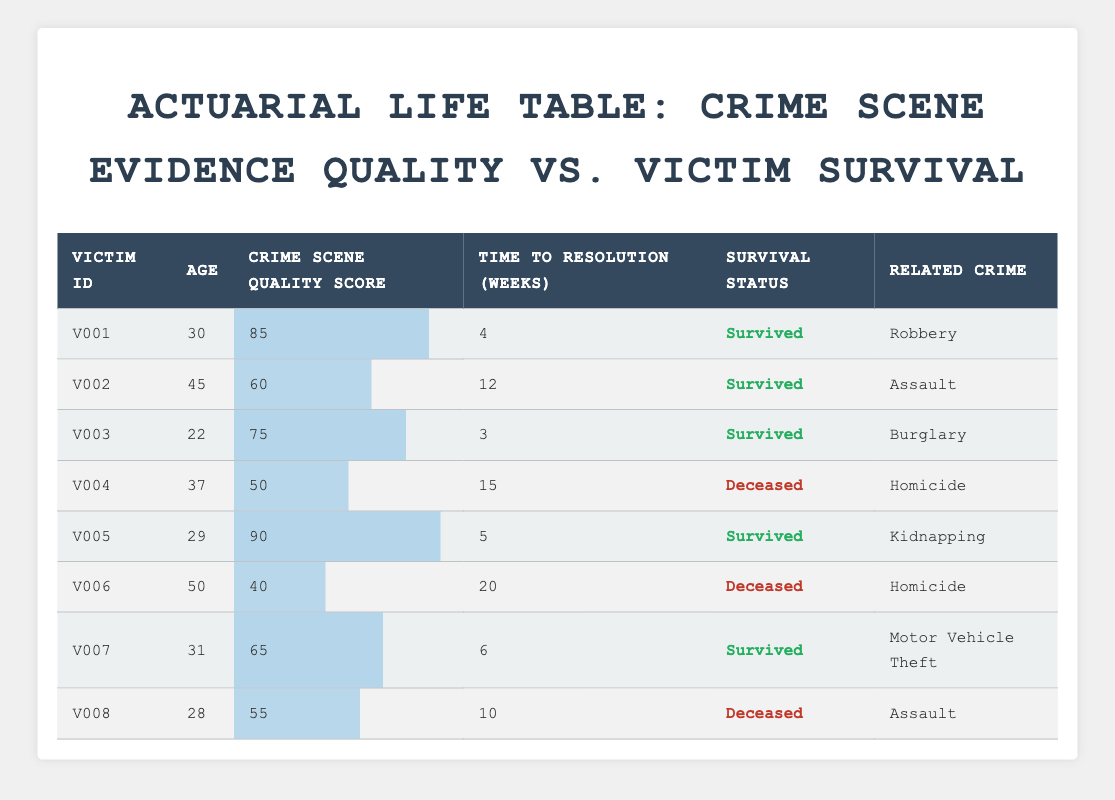What is the age of the youngest victim? By examining the age column, the youngest victim is identified as V003, who is 22 years old.
Answer: 22 How many victims survived their incidents? Counting the rows where the survival status is "Survived", we find that there are 5 victims (V001, V002, V003, V005, V007).
Answer: 5 What is the average crime scene quality score of deceased victims? The deceased victims are V004, V006, and V008 with scores of 50, 40, and 55 respectively. To find the average, sum these scores (50 + 40 + 55 = 145) and divide by the count (3). The average is 145 / 3 = 48.33.
Answer: 48.33 Which victim had the longest time to resolution, and how many weeks was it? Reviewing the time to resolution column, we see that the longest time is 20 weeks for victim V006.
Answer: V006, 20 weeks Is there any victim aged over 40 who survived? Looking through the age and survival status columns, we find that V002 (age 45) survived, so the answer is Yes.
Answer: Yes What is the total time to resolution for all victims who survived? Summing the time to resolution for survived victims (4 + 12 + 3 + 5 + 6 = 30) gives a total of 30 weeks.
Answer: 30 weeks How many victims related to homicide are in the data, and what were their survival statuses? Examining the related crime column, we see two homicide cases: V004 (Deceased) and V006 (Deceased). Therefore, there are 2 victims.
Answer: 2 victims, both Deceased What percentage of the victims survived? A total of 8 victims are listed, 5 survived. To find the percentage, calculate (5 / 8) * 100 = 62.5%.
Answer: 62.5% 